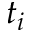Convert formula to latex. <formula><loc_0><loc_0><loc_500><loc_500>t _ { i }</formula> 